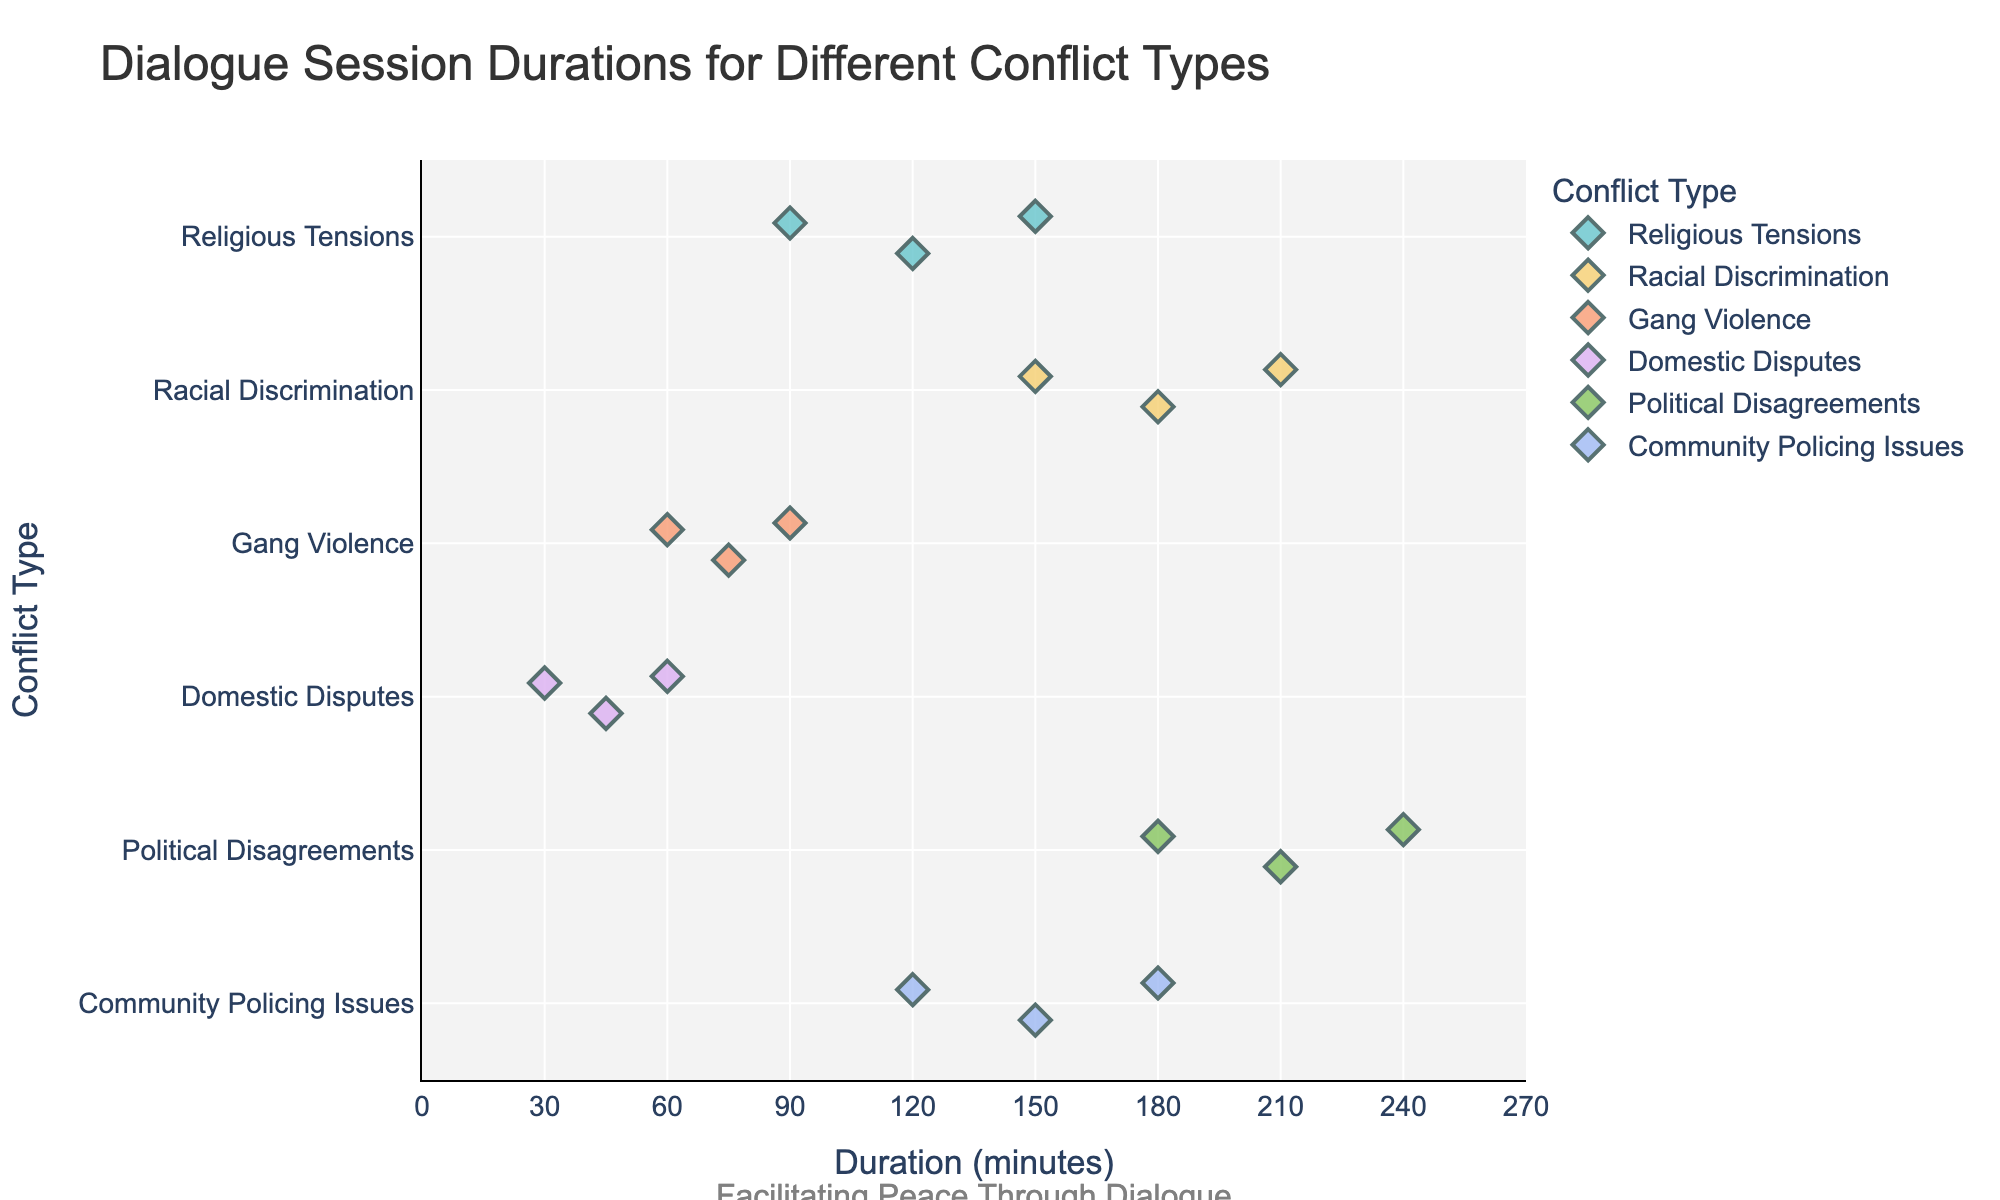What is the title of the plot? The title is displayed at the top of the figure and reads "Dialogue Session Durations for Different Conflict Types".
Answer: Dialogue Session Durations for Different Conflict Types Which conflict type has the longest recorded session duration? The longest recorded session duration can be found by identifying the point farthest to the right. In this case, it is "Political Disagreements" with a duration of 240 minutes.
Answer: Political Disagreements How many dialogue sessions are recorded for "Gang Violence"? The number of sessions for "Gang Violence" can be counted by identifying the number of points along its corresponding axis. There are three points for "Gang Violence".
Answer: 3 Which conflict type has the shortest recorded session duration? The shortest duration appears as the point farthest to the left. "Domestic Disputes" has the shortest duration with 30 minutes.
Answer: Domestic Disputes What is the average duration of sessions for "Religious Tensions"? By averaging the durations for "Religious Tensions" (120, 90, 150): (120 + 90 + 150) / 3 = 360 / 3 = 120
Answer: 120 How do the average session durations for "Racial Discrimination" and "Community Policing Issues" compare? Calculate the averages: "Racial Discrimination" (180, 150, 210) = (180 + 150 + 210) / 3 = 540 / 3 = 180; "Community Policing Issues" (120, 150, 180) = (120 + 150 + 180) / 3 = 450 / 3 = 150. Both averages are 180 and 150 minutes respectively.
Answer: Racial Discrimination: 180, Community Policing Issues: 150 Which conflict type shows the most variation in session duration? The variation is indicated by the spread of the points horizontally. By visually examining, "Political Disagreements" shows the most spread ranging from 180 to 240 minutes.
Answer: Political Disagreements Which conflict type has the most consistent session durations? Consistency in duration is indicated by the clustering of points. "Domestic Disputes" with durations of 30, 45, and 60 minutes show clustering around shorter durations.
Answer: Domestic Disputes How many dialogue sessions lasted exactly 150 minutes? By identifying points at the position marked 150 minutes: There are sessions in "Religious Tensions", "Racial Discrimination", and "Community Policing Issues", making it three sessions.
Answer: 3 